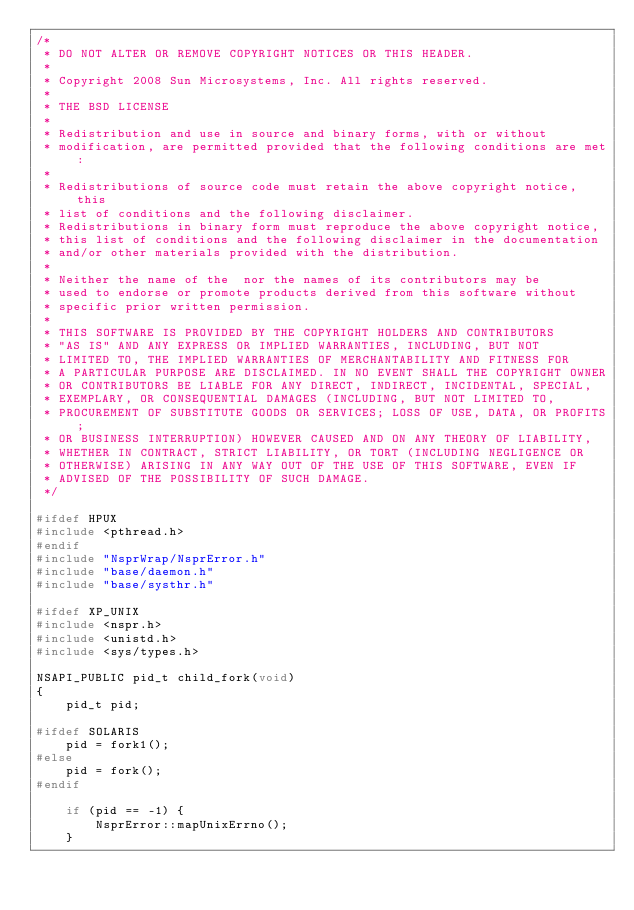Convert code to text. <code><loc_0><loc_0><loc_500><loc_500><_C++_>/*
 * DO NOT ALTER OR REMOVE COPYRIGHT NOTICES OR THIS HEADER.
 *
 * Copyright 2008 Sun Microsystems, Inc. All rights reserved.
 *
 * THE BSD LICENSE
 *
 * Redistribution and use in source and binary forms, with or without 
 * modification, are permitted provided that the following conditions are met:
 *
 * Redistributions of source code must retain the above copyright notice, this
 * list of conditions and the following disclaimer. 
 * Redistributions in binary form must reproduce the above copyright notice, 
 * this list of conditions and the following disclaimer in the documentation
 * and/or other materials provided with the distribution. 
 *
 * Neither the name of the  nor the names of its contributors may be
 * used to endorse or promote products derived from this software without 
 * specific prior written permission. 
 *
 * THIS SOFTWARE IS PROVIDED BY THE COPYRIGHT HOLDERS AND CONTRIBUTORS
 * "AS IS" AND ANY EXPRESS OR IMPLIED WARRANTIES, INCLUDING, BUT NOT
 * LIMITED TO, THE IMPLIED WARRANTIES OF MERCHANTABILITY AND FITNESS FOR
 * A PARTICULAR PURPOSE ARE DISCLAIMED. IN NO EVENT SHALL THE COPYRIGHT OWNER 
 * OR CONTRIBUTORS BE LIABLE FOR ANY DIRECT, INDIRECT, INCIDENTAL, SPECIAL,
 * EXEMPLARY, OR CONSEQUENTIAL DAMAGES (INCLUDING, BUT NOT LIMITED TO, 
 * PROCUREMENT OF SUBSTITUTE GOODS OR SERVICES; LOSS OF USE, DATA, OR PROFITS; 
 * OR BUSINESS INTERRUPTION) HOWEVER CAUSED AND ON ANY THEORY OF LIABILITY, 
 * WHETHER IN CONTRACT, STRICT LIABILITY, OR TORT (INCLUDING NEGLIGENCE OR 
 * OTHERWISE) ARISING IN ANY WAY OUT OF THE USE OF THIS SOFTWARE, EVEN IF 
 * ADVISED OF THE POSSIBILITY OF SUCH DAMAGE.
 */

#ifdef HPUX
#include <pthread.h>
#endif
#include "NsprWrap/NsprError.h"
#include "base/daemon.h"
#include "base/systhr.h"

#ifdef XP_UNIX
#include <nspr.h>
#include <unistd.h>
#include <sys/types.h>

NSAPI_PUBLIC pid_t child_fork(void) 
{
    pid_t pid;

#ifdef SOLARIS
    pid = fork1();
#else
    pid = fork();
#endif

    if (pid == -1) {
        NsprError::mapUnixErrno();
    }
</code> 